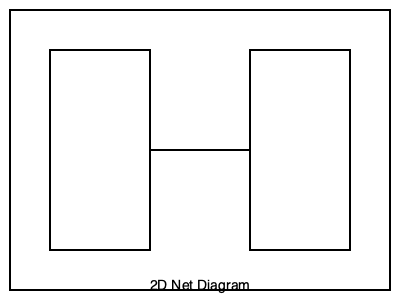As a cognitive behavioral therapist working with patients who have spatial anxiety, you're developing a therapeutic exercise involving 3D shapes. Given the 2D net diagram above, which 3D shape would it form when folded along the edges? To determine the 3D shape from the given 2D net diagram, let's analyze it step-by-step:

1. Identify the shape of the faces:
   - The net consists of six squares of equal size.

2. Count the number of faces:
   - There are 6 squares in total.

3. Analyze the arrangement:
   - The squares are connected in a cross-like pattern.
   - There's a central column of 4 squares.
   - Two additional squares are attached to the sides of the second square from the top.

4. Visualize the folding process:
   - The top and bottom squares of the central column would form the top and bottom faces.
   - The two middle squares of the central column would form the front and back faces.
   - The two side squares would fold to form the left and right faces.

5. Recognize the resulting shape:
   - A shape with 6 square faces, where each face is connected to 4 other faces at right angles.

6. Conclude:
   - This arrangement of 6 square faces folding at right angles forms a cube.

In the context of cognitive behavioral therapy, understanding this spatial relationship can help patients with spatial anxiety to break down complex visual information into manageable steps, potentially reducing anxiety associated with spatial tasks.
Answer: Cube 